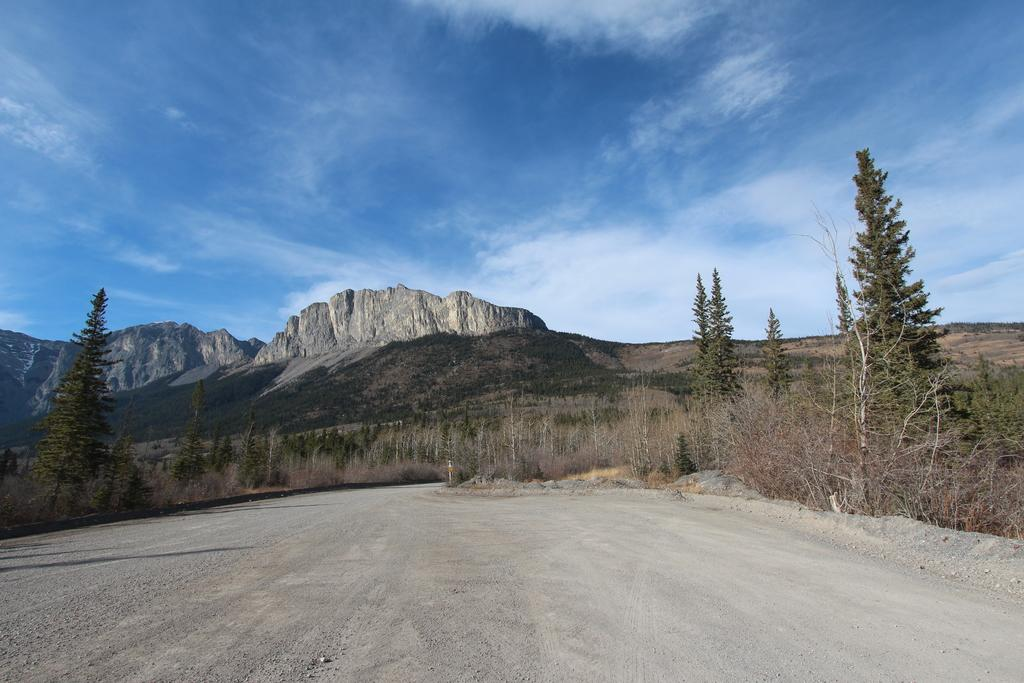What is located in the center of the image? There are trees and mountains in the center of the image. What can be seen at the bottom of the image? There is a road at the bottom of the image. What is visible at the top of the image? The sky is visible at the top of the image. Can you hear the whistle of the wind blowing through the trees in the image? There is no sound present in the image, so it is not possible to hear any whistling. What type of territory is depicted in the image? The image does not show any specific territory or geographical location; it simply features trees, mountains, a road, and the sky. 